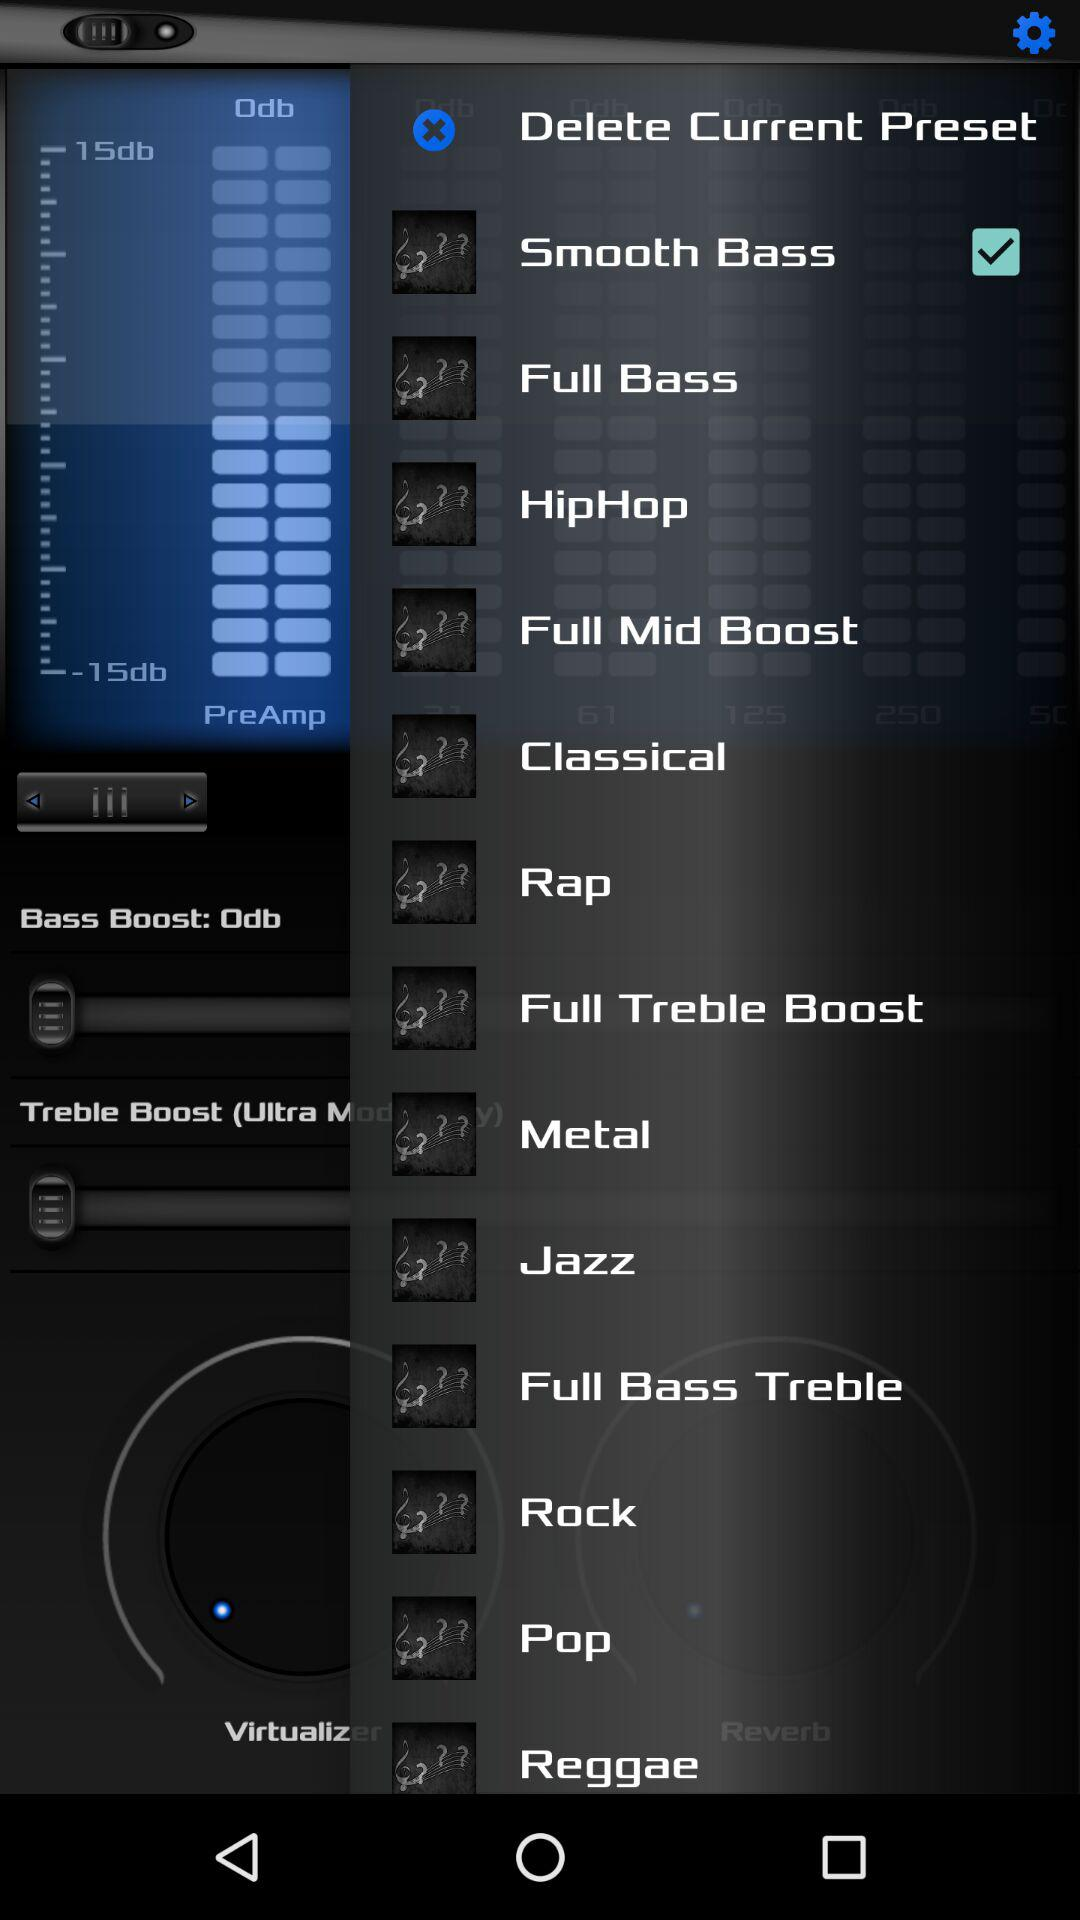Is "Smooth Bass" selected or not? "Smooth Bass" is selected. 